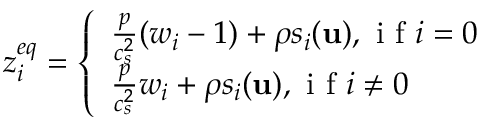Convert formula to latex. <formula><loc_0><loc_0><loc_500><loc_500>z _ { i } ^ { e q } = \left \{ \begin{array} { l l } { \frac { p } { c _ { s } ^ { 2 } } ( w _ { i } - 1 ) + \rho s _ { i } ( u ) , i f i = 0 } \\ { \frac { p } { c _ { s } ^ { 2 } } w _ { i } + \rho s _ { i } ( u ) , i f i \neq 0 } \end{array}</formula> 